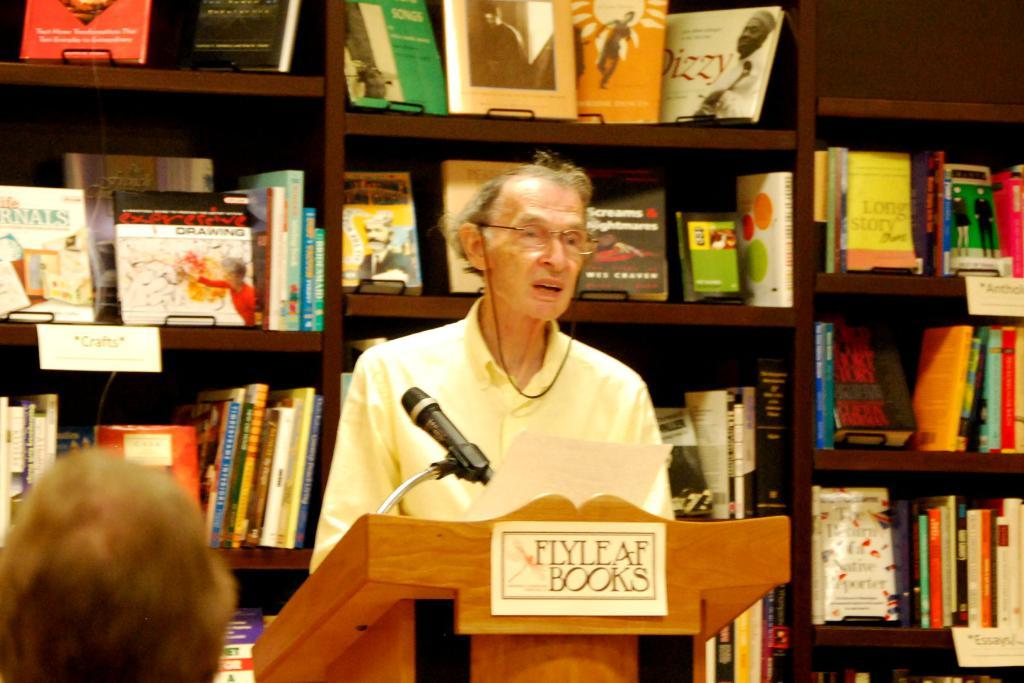<image>
Summarize the visual content of the image. a man is talking at a podium labeled Flyleaf Books 